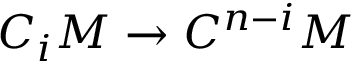Convert formula to latex. <formula><loc_0><loc_0><loc_500><loc_500>C _ { i } M \to C ^ { n - i } M</formula> 